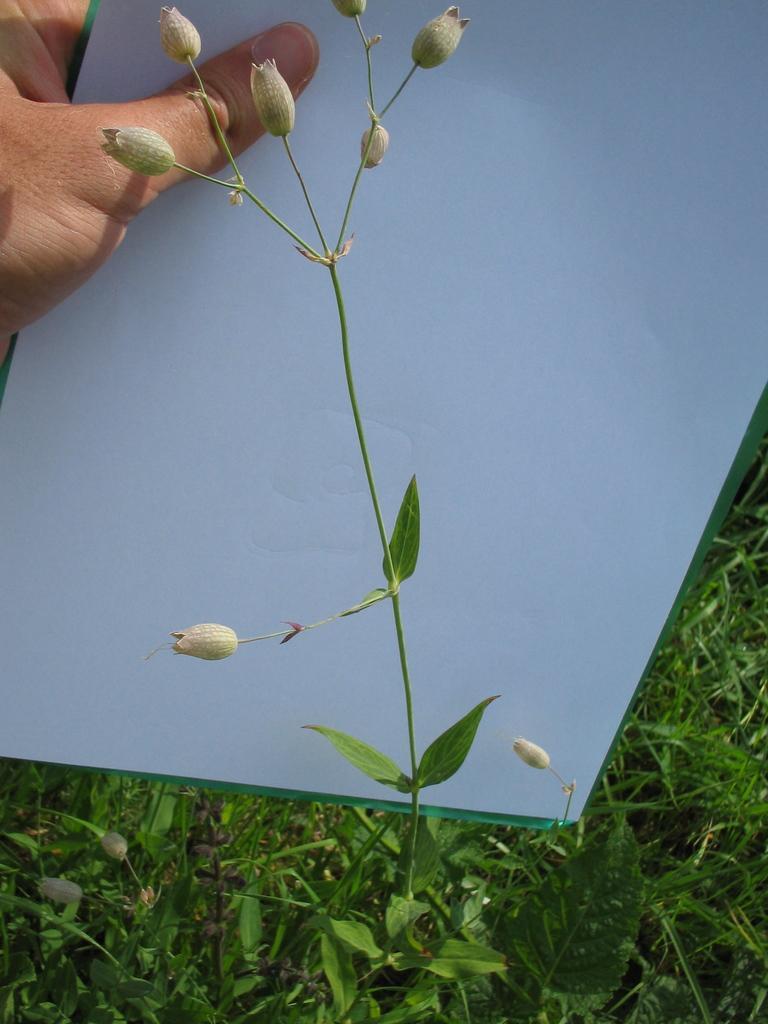Describe this image in one or two sentences. In the center of the image we can see a plant and flowers. In the background of the image we can see the grass and a person is holding a paper. 